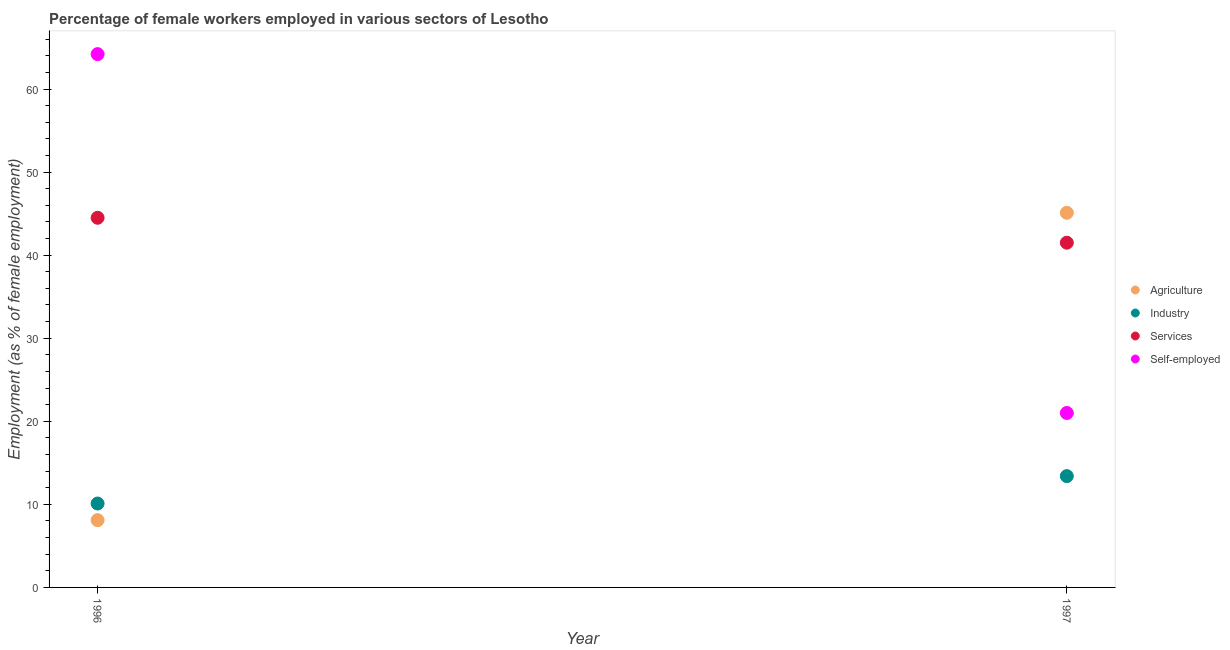How many different coloured dotlines are there?
Keep it short and to the point. 4. Is the number of dotlines equal to the number of legend labels?
Your answer should be compact. Yes. What is the percentage of self employed female workers in 1997?
Ensure brevity in your answer.  21. Across all years, what is the maximum percentage of self employed female workers?
Ensure brevity in your answer.  64.2. Across all years, what is the minimum percentage of self employed female workers?
Keep it short and to the point. 21. In which year was the percentage of female workers in agriculture maximum?
Give a very brief answer. 1997. What is the total percentage of self employed female workers in the graph?
Give a very brief answer. 85.2. What is the difference between the percentage of female workers in agriculture in 1996 and that in 1997?
Make the answer very short. -37. What is the difference between the percentage of female workers in services in 1997 and the percentage of female workers in agriculture in 1996?
Offer a terse response. 33.4. What is the average percentage of self employed female workers per year?
Offer a terse response. 42.6. In the year 1997, what is the difference between the percentage of self employed female workers and percentage of female workers in industry?
Your answer should be compact. 7.6. In how many years, is the percentage of female workers in industry greater than 30 %?
Ensure brevity in your answer.  0. What is the ratio of the percentage of female workers in industry in 1996 to that in 1997?
Keep it short and to the point. 0.75. Is the percentage of self employed female workers in 1996 less than that in 1997?
Your answer should be compact. No. Is it the case that in every year, the sum of the percentage of female workers in agriculture and percentage of self employed female workers is greater than the sum of percentage of female workers in services and percentage of female workers in industry?
Your response must be concise. No. Does the percentage of female workers in industry monotonically increase over the years?
Offer a very short reply. Yes. How many dotlines are there?
Your response must be concise. 4. How many years are there in the graph?
Give a very brief answer. 2. What is the difference between two consecutive major ticks on the Y-axis?
Offer a terse response. 10. What is the title of the graph?
Provide a succinct answer. Percentage of female workers employed in various sectors of Lesotho. Does "Fiscal policy" appear as one of the legend labels in the graph?
Ensure brevity in your answer.  No. What is the label or title of the Y-axis?
Your response must be concise. Employment (as % of female employment). What is the Employment (as % of female employment) of Agriculture in 1996?
Make the answer very short. 8.1. What is the Employment (as % of female employment) in Industry in 1996?
Your answer should be very brief. 10.1. What is the Employment (as % of female employment) in Services in 1996?
Provide a succinct answer. 44.5. What is the Employment (as % of female employment) of Self-employed in 1996?
Make the answer very short. 64.2. What is the Employment (as % of female employment) of Agriculture in 1997?
Offer a very short reply. 45.1. What is the Employment (as % of female employment) of Industry in 1997?
Your response must be concise. 13.4. What is the Employment (as % of female employment) in Services in 1997?
Your answer should be very brief. 41.5. What is the Employment (as % of female employment) of Self-employed in 1997?
Give a very brief answer. 21. Across all years, what is the maximum Employment (as % of female employment) of Agriculture?
Give a very brief answer. 45.1. Across all years, what is the maximum Employment (as % of female employment) of Industry?
Provide a succinct answer. 13.4. Across all years, what is the maximum Employment (as % of female employment) in Services?
Offer a terse response. 44.5. Across all years, what is the maximum Employment (as % of female employment) in Self-employed?
Offer a terse response. 64.2. Across all years, what is the minimum Employment (as % of female employment) of Agriculture?
Provide a succinct answer. 8.1. Across all years, what is the minimum Employment (as % of female employment) of Industry?
Your response must be concise. 10.1. Across all years, what is the minimum Employment (as % of female employment) of Services?
Provide a short and direct response. 41.5. Across all years, what is the minimum Employment (as % of female employment) of Self-employed?
Offer a terse response. 21. What is the total Employment (as % of female employment) in Agriculture in the graph?
Ensure brevity in your answer.  53.2. What is the total Employment (as % of female employment) of Industry in the graph?
Give a very brief answer. 23.5. What is the total Employment (as % of female employment) in Services in the graph?
Keep it short and to the point. 86. What is the total Employment (as % of female employment) of Self-employed in the graph?
Your response must be concise. 85.2. What is the difference between the Employment (as % of female employment) of Agriculture in 1996 and that in 1997?
Ensure brevity in your answer.  -37. What is the difference between the Employment (as % of female employment) of Self-employed in 1996 and that in 1997?
Your answer should be compact. 43.2. What is the difference between the Employment (as % of female employment) in Agriculture in 1996 and the Employment (as % of female employment) in Services in 1997?
Your answer should be very brief. -33.4. What is the difference between the Employment (as % of female employment) in Agriculture in 1996 and the Employment (as % of female employment) in Self-employed in 1997?
Ensure brevity in your answer.  -12.9. What is the difference between the Employment (as % of female employment) of Industry in 1996 and the Employment (as % of female employment) of Services in 1997?
Ensure brevity in your answer.  -31.4. What is the difference between the Employment (as % of female employment) of Services in 1996 and the Employment (as % of female employment) of Self-employed in 1997?
Keep it short and to the point. 23.5. What is the average Employment (as % of female employment) in Agriculture per year?
Provide a succinct answer. 26.6. What is the average Employment (as % of female employment) of Industry per year?
Provide a short and direct response. 11.75. What is the average Employment (as % of female employment) of Services per year?
Your answer should be very brief. 43. What is the average Employment (as % of female employment) in Self-employed per year?
Your response must be concise. 42.6. In the year 1996, what is the difference between the Employment (as % of female employment) in Agriculture and Employment (as % of female employment) in Services?
Your response must be concise. -36.4. In the year 1996, what is the difference between the Employment (as % of female employment) of Agriculture and Employment (as % of female employment) of Self-employed?
Your response must be concise. -56.1. In the year 1996, what is the difference between the Employment (as % of female employment) of Industry and Employment (as % of female employment) of Services?
Keep it short and to the point. -34.4. In the year 1996, what is the difference between the Employment (as % of female employment) of Industry and Employment (as % of female employment) of Self-employed?
Give a very brief answer. -54.1. In the year 1996, what is the difference between the Employment (as % of female employment) in Services and Employment (as % of female employment) in Self-employed?
Give a very brief answer. -19.7. In the year 1997, what is the difference between the Employment (as % of female employment) in Agriculture and Employment (as % of female employment) in Industry?
Your response must be concise. 31.7. In the year 1997, what is the difference between the Employment (as % of female employment) of Agriculture and Employment (as % of female employment) of Services?
Your answer should be very brief. 3.6. In the year 1997, what is the difference between the Employment (as % of female employment) in Agriculture and Employment (as % of female employment) in Self-employed?
Provide a succinct answer. 24.1. In the year 1997, what is the difference between the Employment (as % of female employment) in Industry and Employment (as % of female employment) in Services?
Ensure brevity in your answer.  -28.1. What is the ratio of the Employment (as % of female employment) of Agriculture in 1996 to that in 1997?
Provide a short and direct response. 0.18. What is the ratio of the Employment (as % of female employment) of Industry in 1996 to that in 1997?
Give a very brief answer. 0.75. What is the ratio of the Employment (as % of female employment) in Services in 1996 to that in 1997?
Provide a short and direct response. 1.07. What is the ratio of the Employment (as % of female employment) in Self-employed in 1996 to that in 1997?
Make the answer very short. 3.06. What is the difference between the highest and the second highest Employment (as % of female employment) of Services?
Keep it short and to the point. 3. What is the difference between the highest and the second highest Employment (as % of female employment) of Self-employed?
Offer a very short reply. 43.2. What is the difference between the highest and the lowest Employment (as % of female employment) in Industry?
Offer a terse response. 3.3. What is the difference between the highest and the lowest Employment (as % of female employment) of Services?
Give a very brief answer. 3. What is the difference between the highest and the lowest Employment (as % of female employment) in Self-employed?
Make the answer very short. 43.2. 